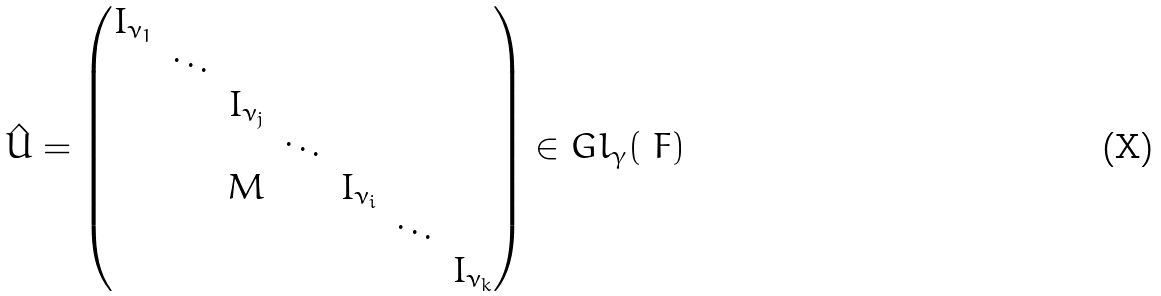<formula> <loc_0><loc_0><loc_500><loc_500>\hat { U } = \begin{pmatrix} I _ { \nu _ { 1 } } & & & & & & \\ & \ddots & & & & & \\ & & I _ { \nu _ { j } } & & & & \\ & & & \ddots & & & \\ & & M & & I _ { \nu _ { i } } & & \\ & & & & & \ddots & \\ & & & & & & I _ { \nu _ { k } } \end{pmatrix} \in G l _ { \gamma } ( \ F )</formula> 